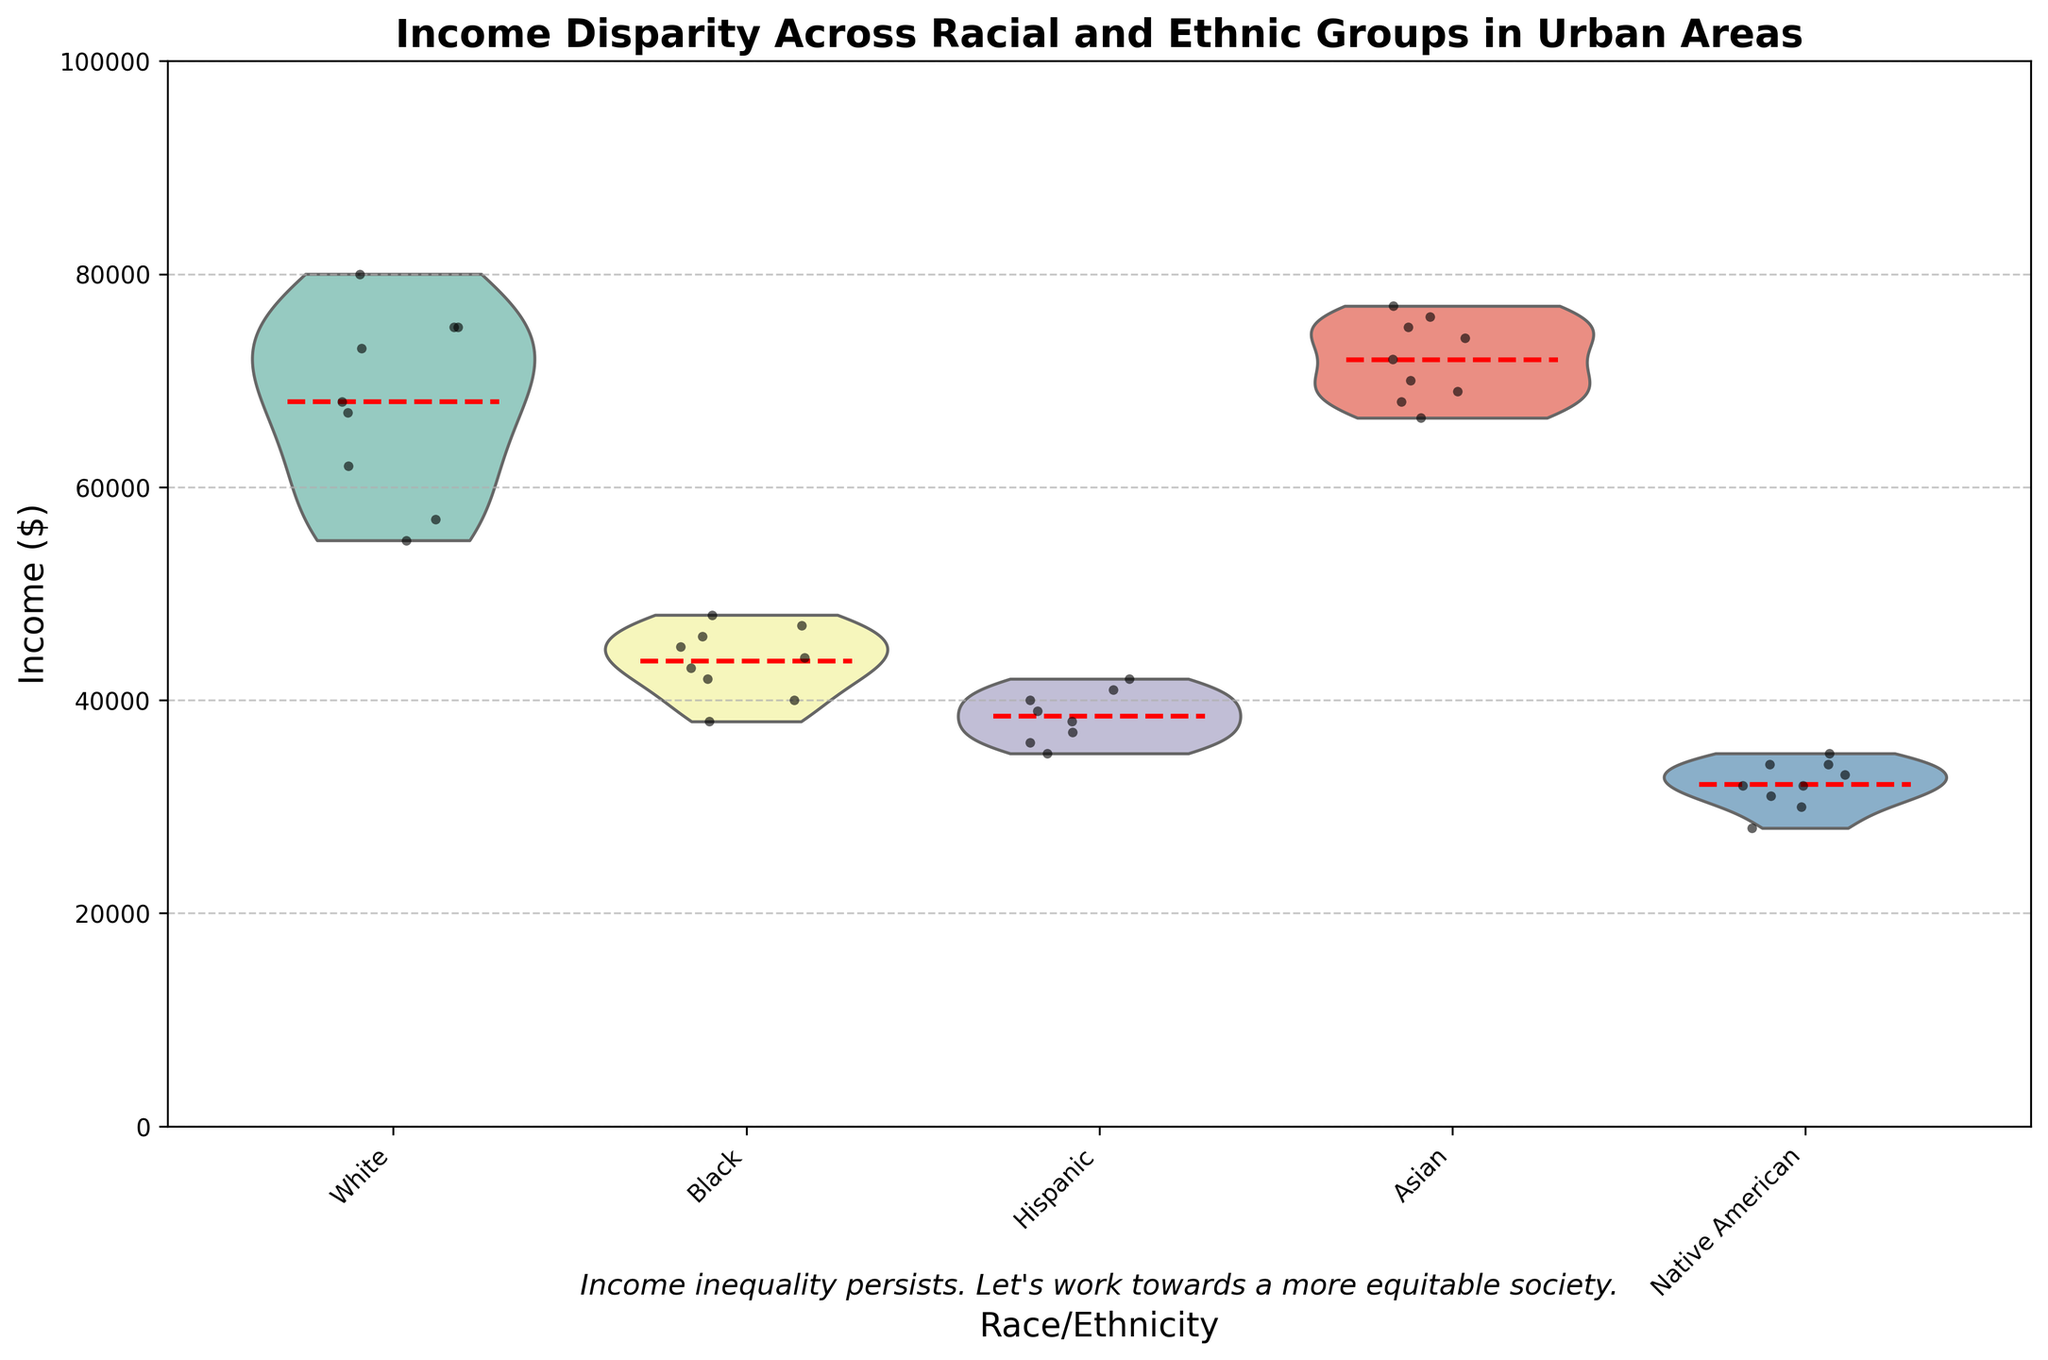What is the title of the chart? The title is positioned at the top of the chart. It reads "Income Disparity Across Racial and Ethnic Groups in Urban Areas".
Answer: Income Disparity Across Racial and Ethnic Groups in Urban Areas Which race/ethnicity has the highest median income according to the violin plot? The violin plot shows the distribution of incomes for each race/ethnicity. The widest part of the violins indicates the median. The Asian group has the highest median income.
Answer: Asian Which race/ethnicity has the lowest median income? The Native American group has the violin plot with its median close to the bottom, indicating the lowest median income among all groups.
Answer: Native American What is the mean income for the Black group as indicated by the dashed red line? The dashed red lines indicate the mean income for each group. Looking at the Black group's violin plot, the red line is positioned slightly above 45,000.
Answer: Around 45,000 How do the income distributions of White and Asian groups compare in terms of spread? The spread of the violin plots (width of the violin) indicates the variability of income within each group. The Asian group's violin plot is wider than the White group's, suggesting a larger spread and more variability in incomes.
Answer: The Asian group has a larger spread Which race/ethnicity displays the highest income point among the data points? The jittered points represent individual incomes. Observing the highest position of any jittered point, the Asian group has the highest income point close to 77,000.
Answer: Asian What is the approximate range of incomes for the Hispanic group? The range can be observed from the top to the bottom of the distribution in the violin plot for the Hispanic group. The incomes roughly range from 35,000 to 42,000.
Answer: 35,000 to 42,000 How does the income distribution of the Black group compare to the Hispanic group in terms of central tendency? The central tendency can be observed through the density of the violin plot and the positions of the jittered points. The Black group's central tendency is higher, around 45,000, compared to the Hispanic group's 38,000-40,000.
Answer: The Black group has a higher central tendency What does the italicized text at the bottom of the chart convey? The text at the bottom addresses social justice by stating, "Income inequality persists. Let's work towards a more equitable society."
Answer: Income inequality persists. Let's work towards a more equitable society Which racial/ethnic group has the smallest spread in their income distribution based on their violin plot? The spread is indicated by the width of the violin plot. The Hispanic group's violin plot appears to have the smallest spread, indicating less variability in their income distribution.
Answer: Hispanic 